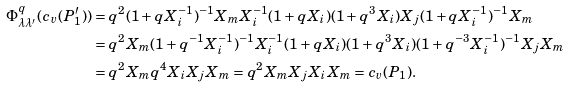Convert formula to latex. <formula><loc_0><loc_0><loc_500><loc_500>\Phi _ { \lambda \lambda ^ { \prime } } ^ { q } ( c _ { v } ( P _ { 1 } ^ { \prime } ) ) & = q ^ { 2 } ( 1 + q X _ { i } ^ { - 1 } ) ^ { - 1 } X _ { m } X _ { i } ^ { - 1 } ( 1 + q X _ { i } ) ( 1 + q ^ { 3 } X _ { i } ) X _ { j } ( 1 + q X _ { i } ^ { - 1 } ) ^ { - 1 } X _ { m } \\ & = q ^ { 2 } X _ { m } ( 1 + q ^ { - 1 } X _ { i } ^ { - 1 } ) ^ { - 1 } X _ { i } ^ { - 1 } ( 1 + q X _ { i } ) ( 1 + q ^ { 3 } X _ { i } ) ( 1 + q ^ { - 3 } X _ { i } ^ { - 1 } ) ^ { - 1 } X _ { j } X _ { m } \\ & = q ^ { 2 } X _ { m } q ^ { 4 } X _ { i } X _ { j } X _ { m } = q ^ { 2 } X _ { m } X _ { j } X _ { i } X _ { m } = c _ { v } ( P _ { 1 } ) .</formula> 